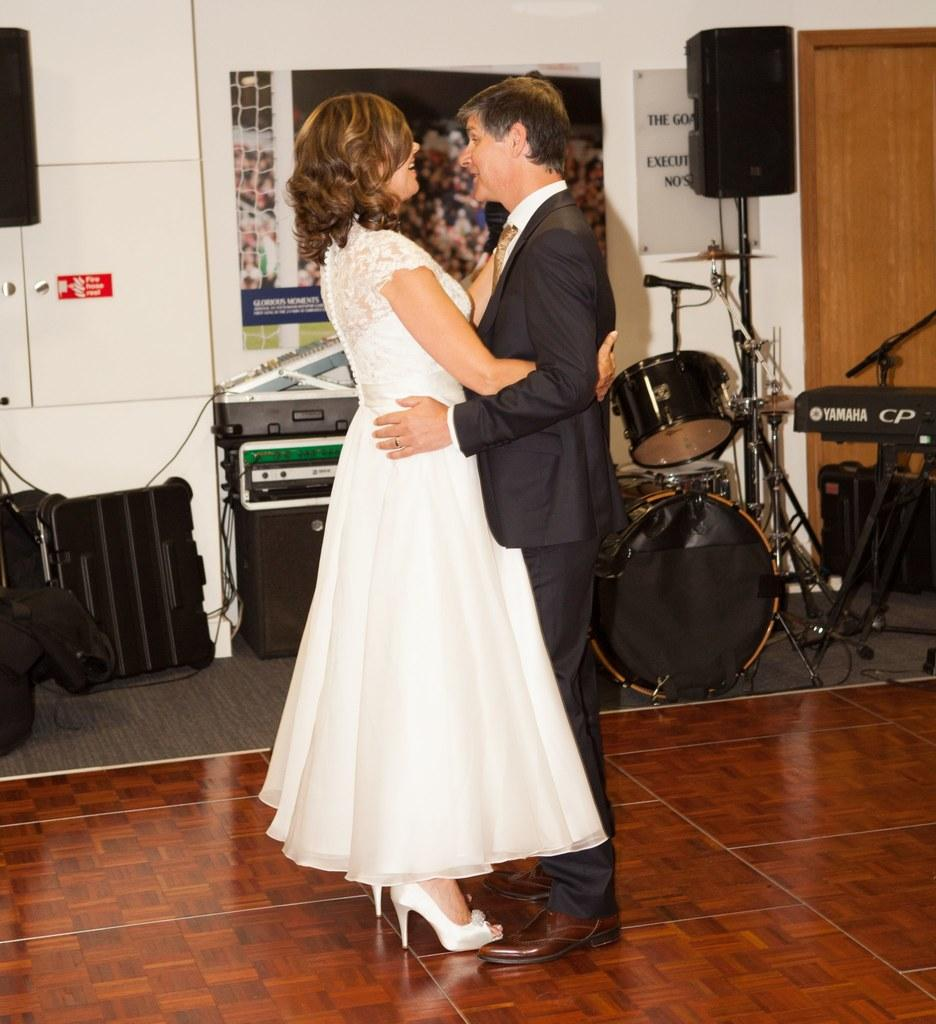How many people are present in the image? There are two people standing in the image. What can be seen in the background of the image? There are musical instruments and a sound system in the background of the image. What type of popcorn is being served at the back of the room in the image? There is no popcorn present in the image, and the term "back" is not relevant to the image's description. 